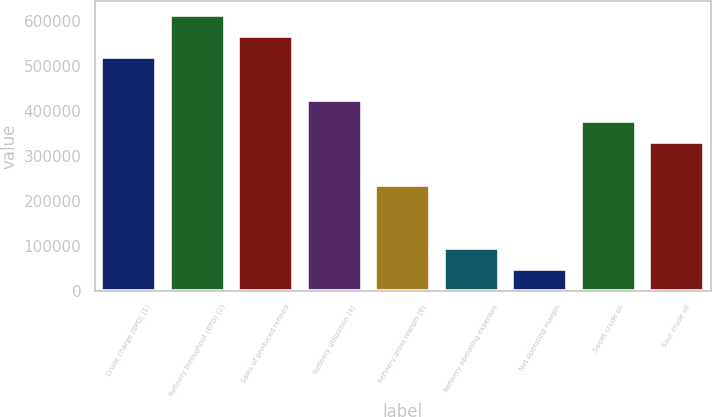Convert chart. <chart><loc_0><loc_0><loc_500><loc_500><bar_chart><fcel>Crude charge (BPD) (1)<fcel>Refinery throughput (BPD) (2)<fcel>Sales of produced refined<fcel>Refinery utilization (4)<fcel>Refinery gross margin (6)<fcel>Refinery operating expenses<fcel>Net operating margin<fcel>Sweet crude oil<fcel>Sour crude oil<nl><fcel>519211<fcel>613612<fcel>566411<fcel>424809<fcel>236007<fcel>94405.2<fcel>47204.6<fcel>377609<fcel>330408<nl></chart> 